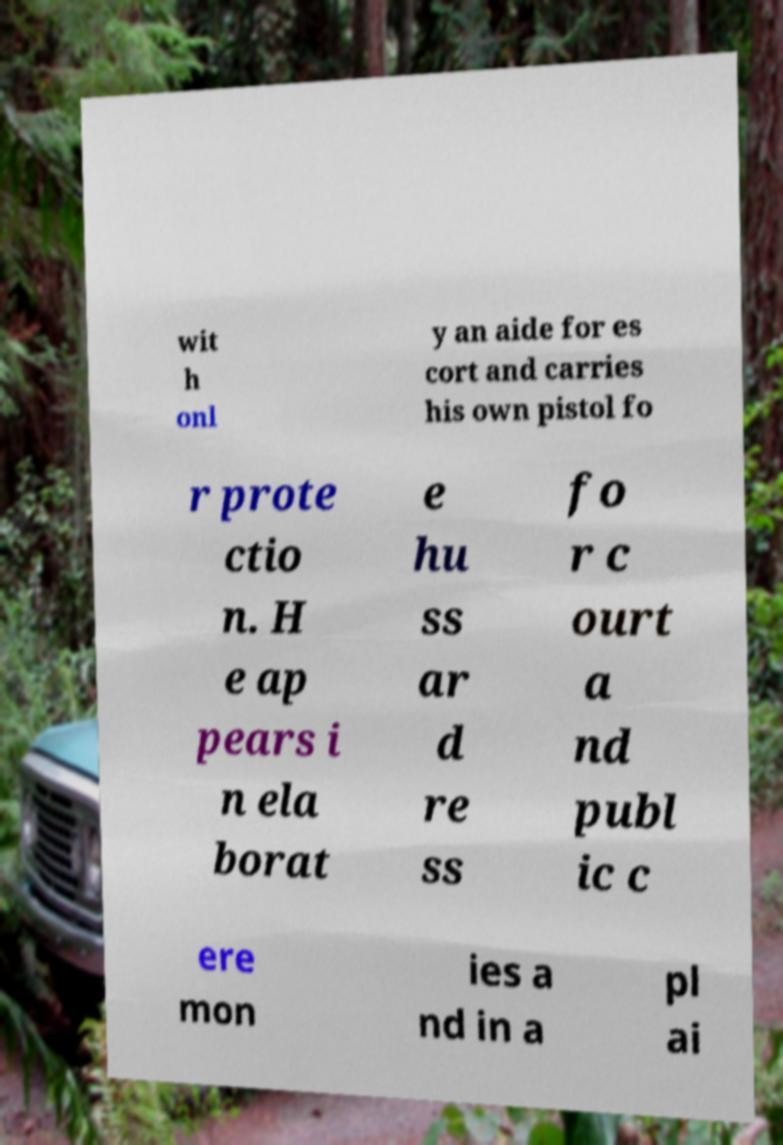For documentation purposes, I need the text within this image transcribed. Could you provide that? wit h onl y an aide for es cort and carries his own pistol fo r prote ctio n. H e ap pears i n ela borat e hu ss ar d re ss fo r c ourt a nd publ ic c ere mon ies a nd in a pl ai 